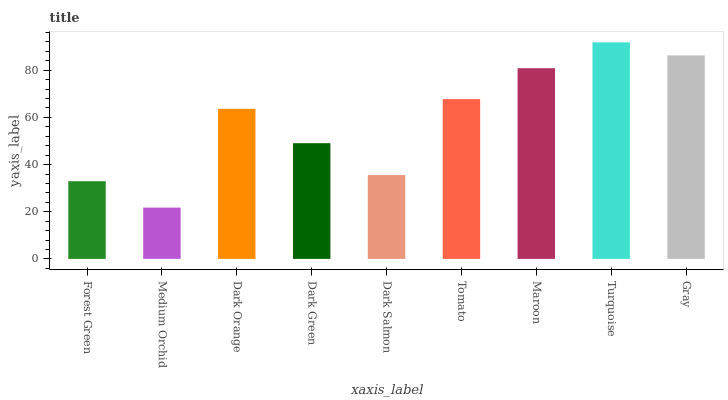Is Medium Orchid the minimum?
Answer yes or no. Yes. Is Turquoise the maximum?
Answer yes or no. Yes. Is Dark Orange the minimum?
Answer yes or no. No. Is Dark Orange the maximum?
Answer yes or no. No. Is Dark Orange greater than Medium Orchid?
Answer yes or no. Yes. Is Medium Orchid less than Dark Orange?
Answer yes or no. Yes. Is Medium Orchid greater than Dark Orange?
Answer yes or no. No. Is Dark Orange less than Medium Orchid?
Answer yes or no. No. Is Dark Orange the high median?
Answer yes or no. Yes. Is Dark Orange the low median?
Answer yes or no. Yes. Is Maroon the high median?
Answer yes or no. No. Is Turquoise the low median?
Answer yes or no. No. 